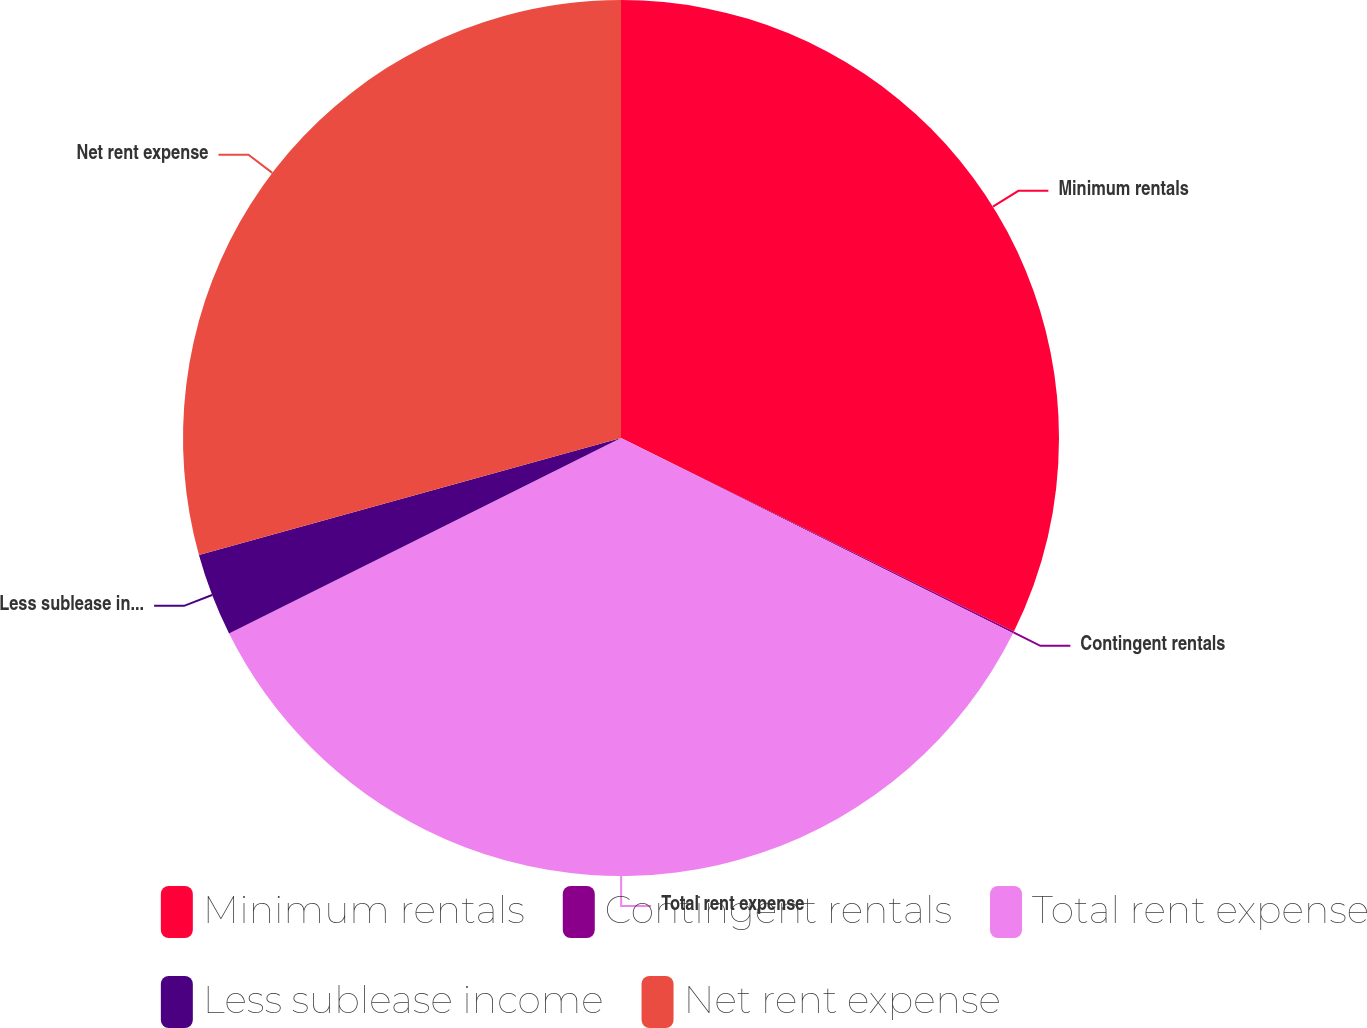Convert chart. <chart><loc_0><loc_0><loc_500><loc_500><pie_chart><fcel>Minimum rentals<fcel>Contingent rentals<fcel>Total rent expense<fcel>Less sublease income<fcel>Net rent expense<nl><fcel>32.29%<fcel>0.07%<fcel>35.28%<fcel>3.06%<fcel>29.31%<nl></chart> 